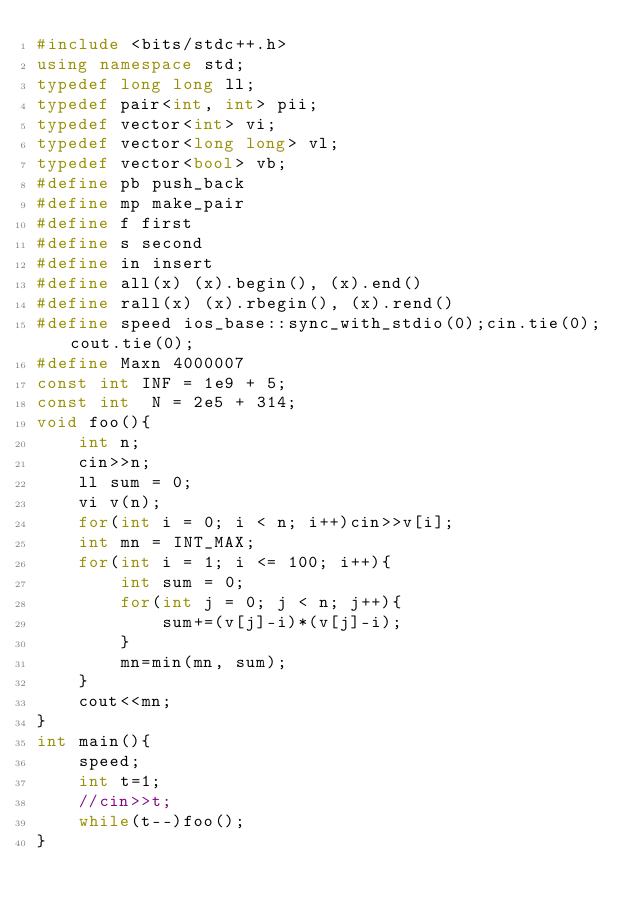Convert code to text. <code><loc_0><loc_0><loc_500><loc_500><_C++_>#include <bits/stdc++.h>
using namespace std;
typedef long long ll;
typedef pair<int, int> pii;
typedef vector<int> vi;
typedef vector<long long> vl;
typedef vector<bool> vb;
#define pb push_back
#define mp make_pair
#define f first
#define s second
#define in insert
#define all(x) (x).begin(), (x).end()
#define rall(x) (x).rbegin(), (x).rend()
#define speed ios_base::sync_with_stdio(0);cin.tie(0);cout.tie(0);
#define Maxn 4000007
const int INF = 1e9 + 5;
const int  N = 2e5 + 314;
void foo(){
    int n;
    cin>>n;
    ll sum = 0;
    vi v(n);
    for(int i = 0; i < n; i++)cin>>v[i];
    int mn = INT_MAX;
    for(int i = 1; i <= 100; i++){
        int sum = 0;
        for(int j = 0; j < n; j++){
            sum+=(v[j]-i)*(v[j]-i);
        }  
        mn=min(mn, sum);
    }
    cout<<mn;
}
int main(){
    speed;
    int t=1;
    //cin>>t;
    while(t--)foo();
}</code> 